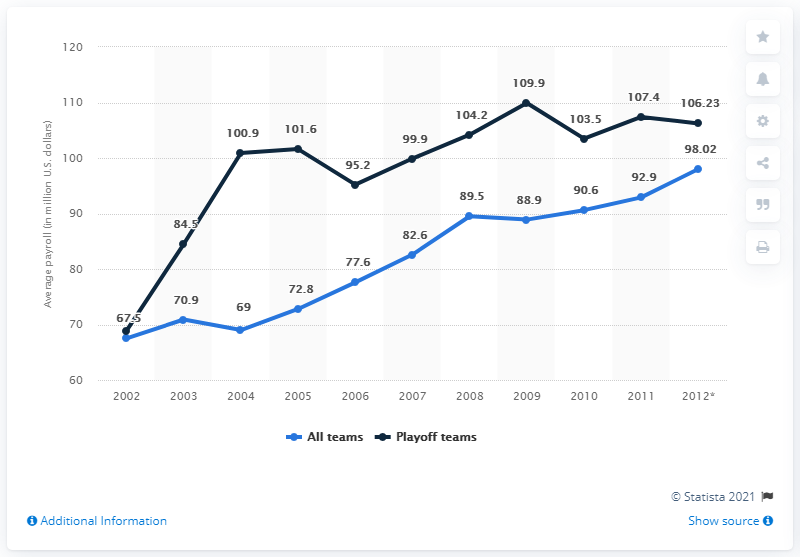Point out several critical features in this image. In 2003, the average payroll of all Major League Baseball (MLB) teams was 70.9 million dollars. 